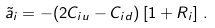Convert formula to latex. <formula><loc_0><loc_0><loc_500><loc_500>\tilde { a } _ { i } & = - ( 2 C _ { i u } - C _ { i d } ) \left [ 1 + R _ { i } \right ] \, .</formula> 